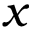Convert formula to latex. <formula><loc_0><loc_0><loc_500><loc_500>x</formula> 